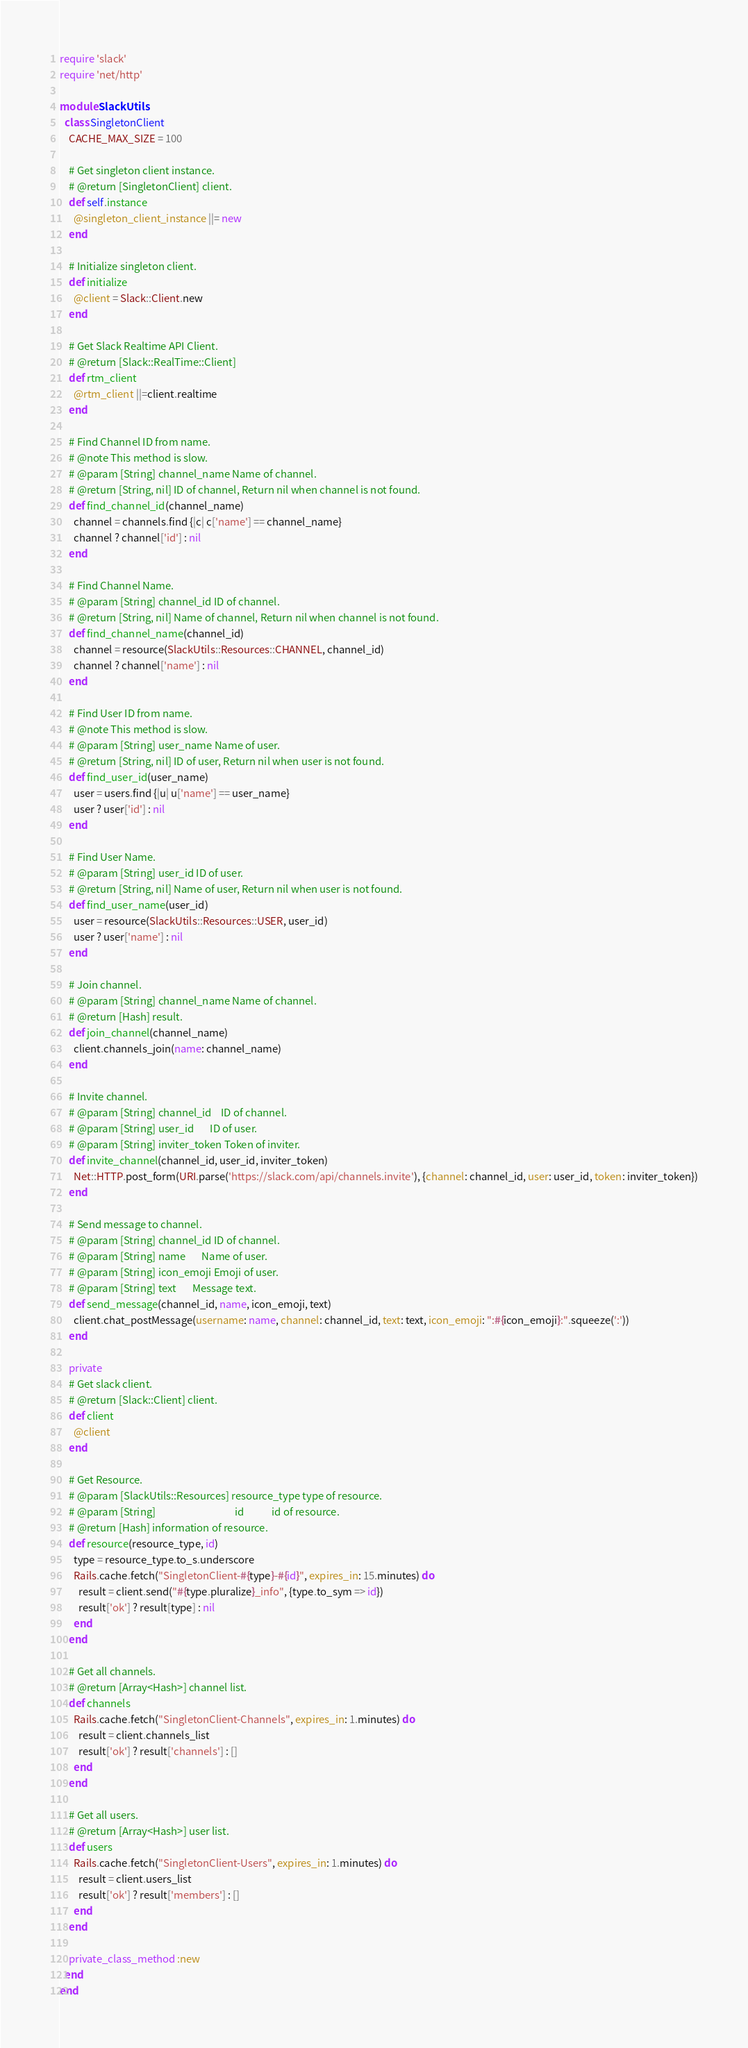<code> <loc_0><loc_0><loc_500><loc_500><_Ruby_>require 'slack'
require 'net/http'

module SlackUtils
  class SingletonClient
    CACHE_MAX_SIZE = 100

    # Get singleton client instance.
    # @return [SingletonClient] client.
    def self.instance
      @singleton_client_instance ||= new
    end

    # Initialize singleton client.
    def initialize
      @client = Slack::Client.new
    end

    # Get Slack Realtime API Client.
    # @return [Slack::RealTime::Client]
    def rtm_client
      @rtm_client ||=client.realtime
    end

    # Find Channel ID from name.
    # @note This method is slow.
    # @param [String] channel_name Name of channel.
    # @return [String, nil] ID of channel, Return nil when channel is not found.
    def find_channel_id(channel_name)
      channel = channels.find {|c| c['name'] == channel_name}
      channel ? channel['id'] : nil
    end

    # Find Channel Name.
    # @param [String] channel_id ID of channel.
    # @return [String, nil] Name of channel, Return nil when channel is not found.
    def find_channel_name(channel_id)
      channel = resource(SlackUtils::Resources::CHANNEL, channel_id)
      channel ? channel['name'] : nil
    end

    # Find User ID from name.
    # @note This method is slow.
    # @param [String] user_name Name of user.
    # @return [String, nil] ID of user, Return nil when user is not found.
    def find_user_id(user_name)
      user = users.find {|u| u['name'] == user_name}
      user ? user['id'] : nil
    end

    # Find User Name.
    # @param [String] user_id ID of user.
    # @return [String, nil] Name of user, Return nil when user is not found.
    def find_user_name(user_id)
      user = resource(SlackUtils::Resources::USER, user_id)
      user ? user['name'] : nil
    end

    # Join channel.
    # @param [String] channel_name Name of channel.
    # @return [Hash] result.
    def join_channel(channel_name)
      client.channels_join(name: channel_name)
    end

    # Invite channel.
    # @param [String] channel_id    ID of channel.
    # @param [String] user_id       ID of user.
    # @param [String] inviter_token Token of inviter.
    def invite_channel(channel_id, user_id, inviter_token)
      Net::HTTP.post_form(URI.parse('https://slack.com/api/channels.invite'), {channel: channel_id, user: user_id, token: inviter_token})
    end

    # Send message to channel.
    # @param [String] channel_id ID of channel.
    # @param [String] name       Name of user.
    # @param [String] icon_emoji Emoji of user.
    # @param [String] text       Message text.
    def send_message(channel_id, name, icon_emoji, text)
      client.chat_postMessage(username: name, channel: channel_id, text: text, icon_emoji: ":#{icon_emoji}:".squeeze(':'))
    end

    private
    # Get slack client.
    # @return [Slack::Client] client.
    def client
      @client
    end

    # Get Resource.
    # @param [SlackUtils::Resources] resource_type type of resource.
    # @param [String]                                  id            id of resource.
    # @return [Hash] information of resource.
    def resource(resource_type, id)
      type = resource_type.to_s.underscore
      Rails.cache.fetch("SingletonClient-#{type}-#{id}", expires_in: 15.minutes) do
        result = client.send("#{type.pluralize}_info", {type.to_sym => id})
        result['ok'] ? result[type] : nil
      end
    end

    # Get all channels.
    # @return [Array<Hash>] channel list.
    def channels
      Rails.cache.fetch("SingletonClient-Channels", expires_in: 1.minutes) do
        result = client.channels_list
        result['ok'] ? result['channels'] : []
      end
    end

    # Get all users.
    # @return [Array<Hash>] user list.
    def users
      Rails.cache.fetch("SingletonClient-Users", expires_in: 1.minutes) do
        result = client.users_list
        result['ok'] ? result['members'] : []
      end
    end

    private_class_method :new
  end
end
</code> 